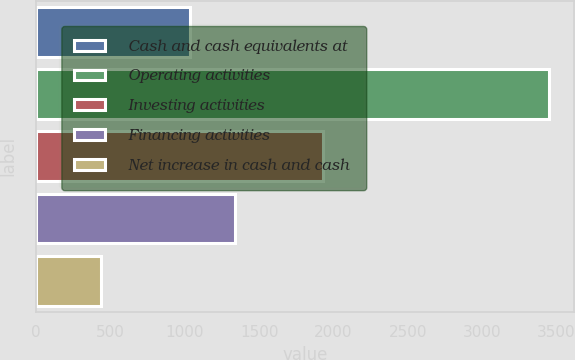Convert chart to OTSL. <chart><loc_0><loc_0><loc_500><loc_500><bar_chart><fcel>Cash and cash equivalents at<fcel>Operating activities<fcel>Investing activities<fcel>Financing activities<fcel>Net increase in cash and cash<nl><fcel>1036<fcel>3448<fcel>1928<fcel>1337.5<fcel>433<nl></chart> 